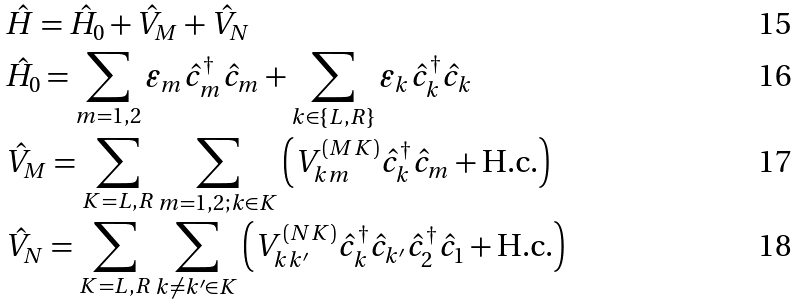<formula> <loc_0><loc_0><loc_500><loc_500>& \hat { H } = \hat { H } _ { 0 } + \hat { V } _ { M } + \hat { V } _ { N } \\ & \hat { H } _ { 0 } = \sum _ { m = 1 , 2 } \varepsilon _ { m } \hat { c } _ { m } ^ { \dagger } \hat { c } _ { m } + \sum _ { k \in \{ L , R \} } \varepsilon _ { k } \hat { c } _ { k } ^ { \dagger } \hat { c } _ { k } \\ & \hat { V } _ { M } = \sum _ { K = L , R } \sum _ { m = 1 , 2 ; k \in K } \left ( V _ { k m } ^ { ( M K ) } \hat { c } _ { k } ^ { \dagger } \hat { c } _ { m } + \text {H.c.} \right ) \\ & \hat { V } _ { N } = \sum _ { K = L , R } \sum _ { k \neq k ^ { \prime } \in K } \left ( V _ { k k ^ { \prime } } ^ { ( N K ) } \hat { c } _ { k } ^ { \dagger } \hat { c } _ { k ^ { \prime } } \hat { c } _ { 2 } ^ { \dagger } \hat { c } _ { 1 } + \text {H.c.} \right )</formula> 